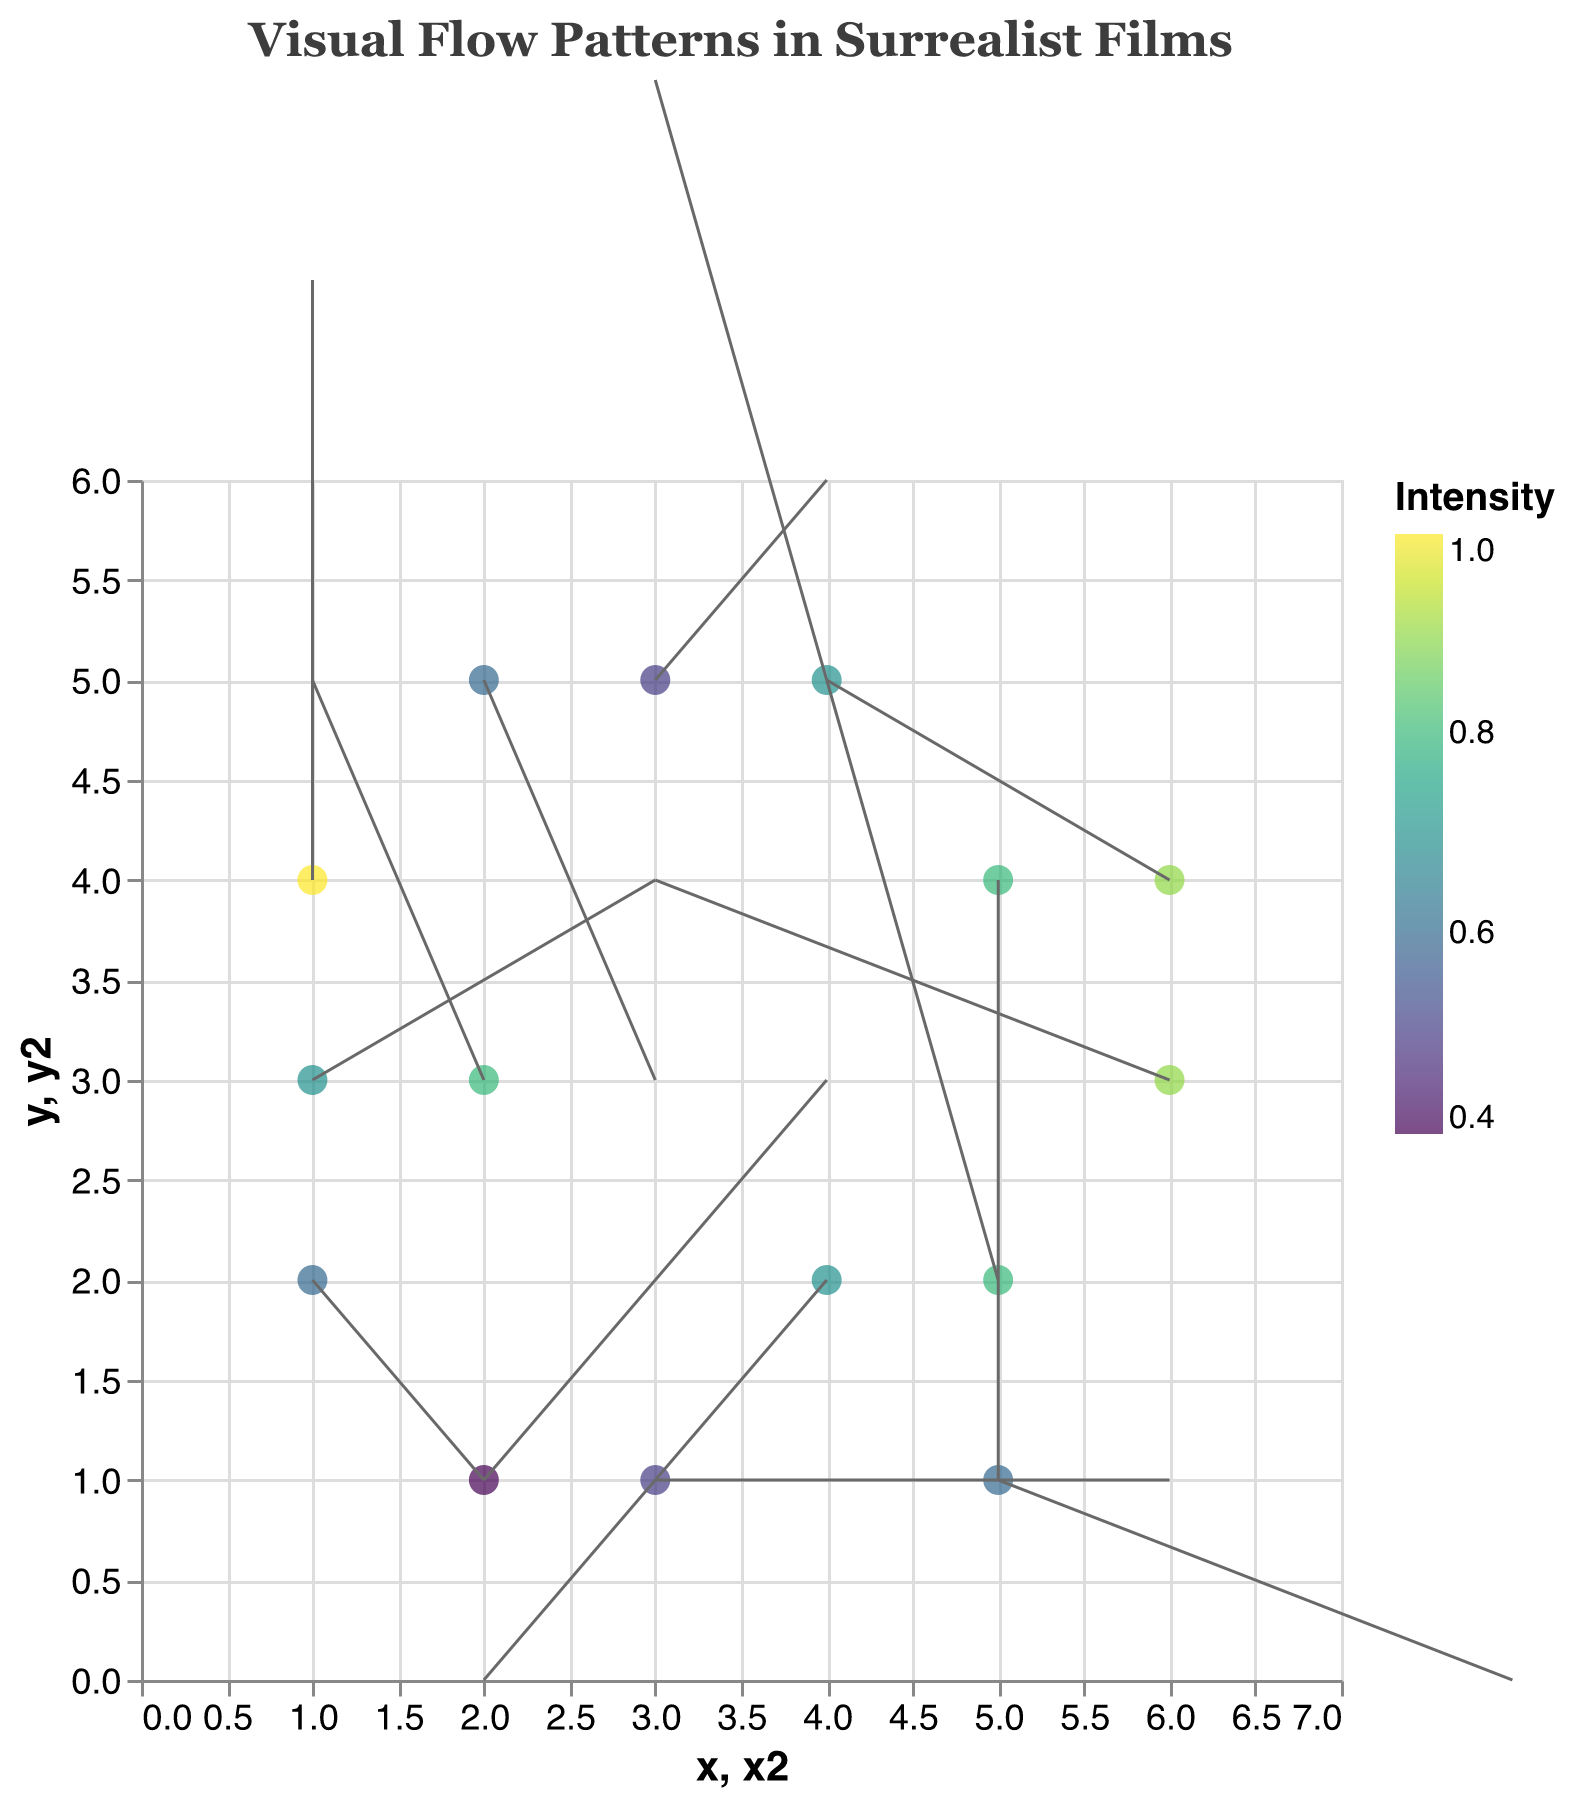What is the title of the figure? The title of the figure is directly available at the top of the plot.
Answer: Visual Flow Patterns in Surrealist Films How many data points are displayed in the figure? Count the number of individual points on the plot.
Answer: 15 Which data point has the highest intensity? Check the color legend and find the point with the color corresponding to the highest intensity value.
Answer: (1, 4) What is the direction of movement at the data point (5, 1)? Examine the rule (arrow) emanating from the point (5, 1) and determine the direction it is pointing. The movement direction is determined by the u and v values.
Answer: Right and down Which data points have a vertical component of movement more than 2? Identify points where the absolute value of v is greater than 2.
Answer: (1, 4) and (5, 4) What is the sum of the x-coordinates of points with intensity greater than or equal to 0.8? Identify points where intensity is >= 0.8, then add their x-coordinates: 2 + 5 + 6 + 5 + 4 = 22.
Answer: 22 Compare the intensity between the points (2, 3) and (3, 5). Which one is higher? Check the intensity values for points (2, 3) and (3, 5) and compare them.
Answer: Point (2, 3) has higher intensity What is the average y-coordinate of points having a negative horizontal component (u)? Identify points with negative u values, sum their y-coordinates and divide by the number of such points: (3 + 2 + 3 + 5 + 5 + 2 + 4) / 7 = 3.43.
Answer: 3.43 Compare the directions of movement at points (4, 2) and (6, 3). Are they similar? Examine the u and v values for both points and determine if their directions are similar: (4, 2) has a direction of (-2, -2) and (6, 3) has a direction of (-3, 1).
Answer: No What is the combined effect of movements at points (1, 3) and (4, 5) in terms of horizontal and vertical components? Sum the u and v values for both points separately: (2 + (-1), 1 + 3) results in (1, 4).
Answer: (1, 4) 